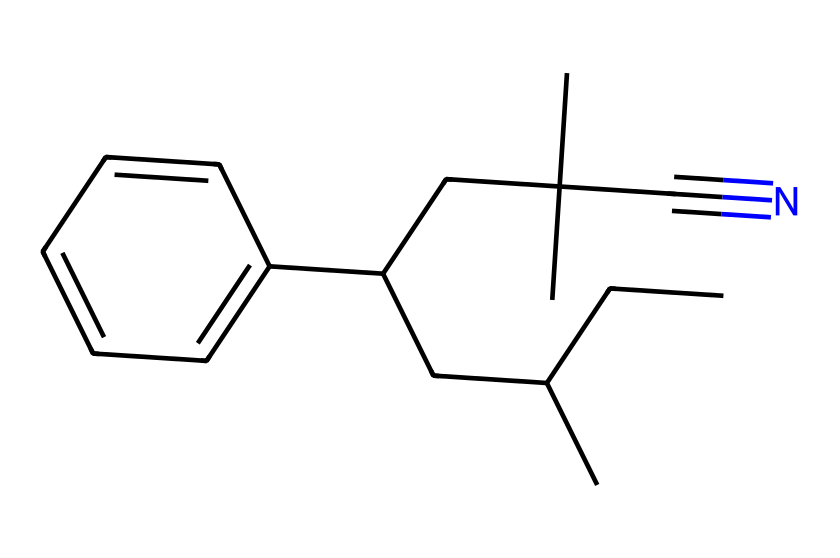What is the functional group present in this chemical structure? The structure contains a nitrile functional group, indicated by the presence of the cyano group (#N) connected to a carbon chain.
Answer: nitrile How many carbon atoms are in this chemical? By counting the carbon atoms represented in the structure, we find there are 15 carbon atoms in total.
Answer: 15 What type of polymer is this likely to form? The presence of aliphatic chains and functional groups suggests that this structure is likely to form a thermoplastic polymer, providing flexibility and impact resistance.
Answer: thermoplastic What is the degree of unsaturation in this chemical? The presence of the triple bond (C#N) indicates a degree of unsaturation in addition to the aromatic ring, resulting in a total degree of unsaturation of 2.
Answer: 2 What main property does the nitrile group contribute to this polymer's effectiveness in emergency vehicles? The nitrile group enhances the chemical resistance and durability of the polymer, which is critical for its application in impact-resistant components of emergency vehicles.
Answer: durability Which part of the structure suggests it has impact resistance? The presence of long aliphatic chains and the cross-linking potential within the carbon framework suggest improved impact resistance.
Answer: long aliphatic chains 